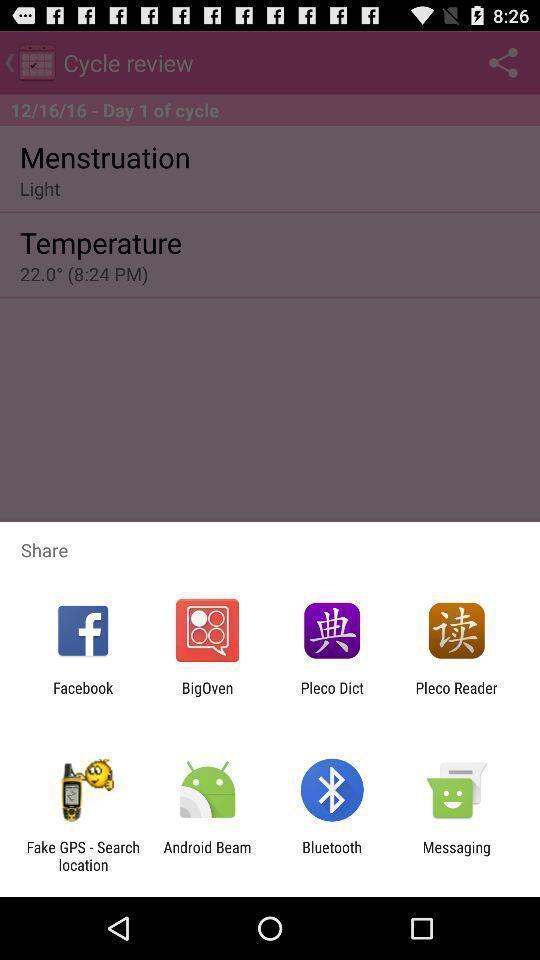Tell me what you see in this picture. Pop-up widget showing lot of data transferring apps. 